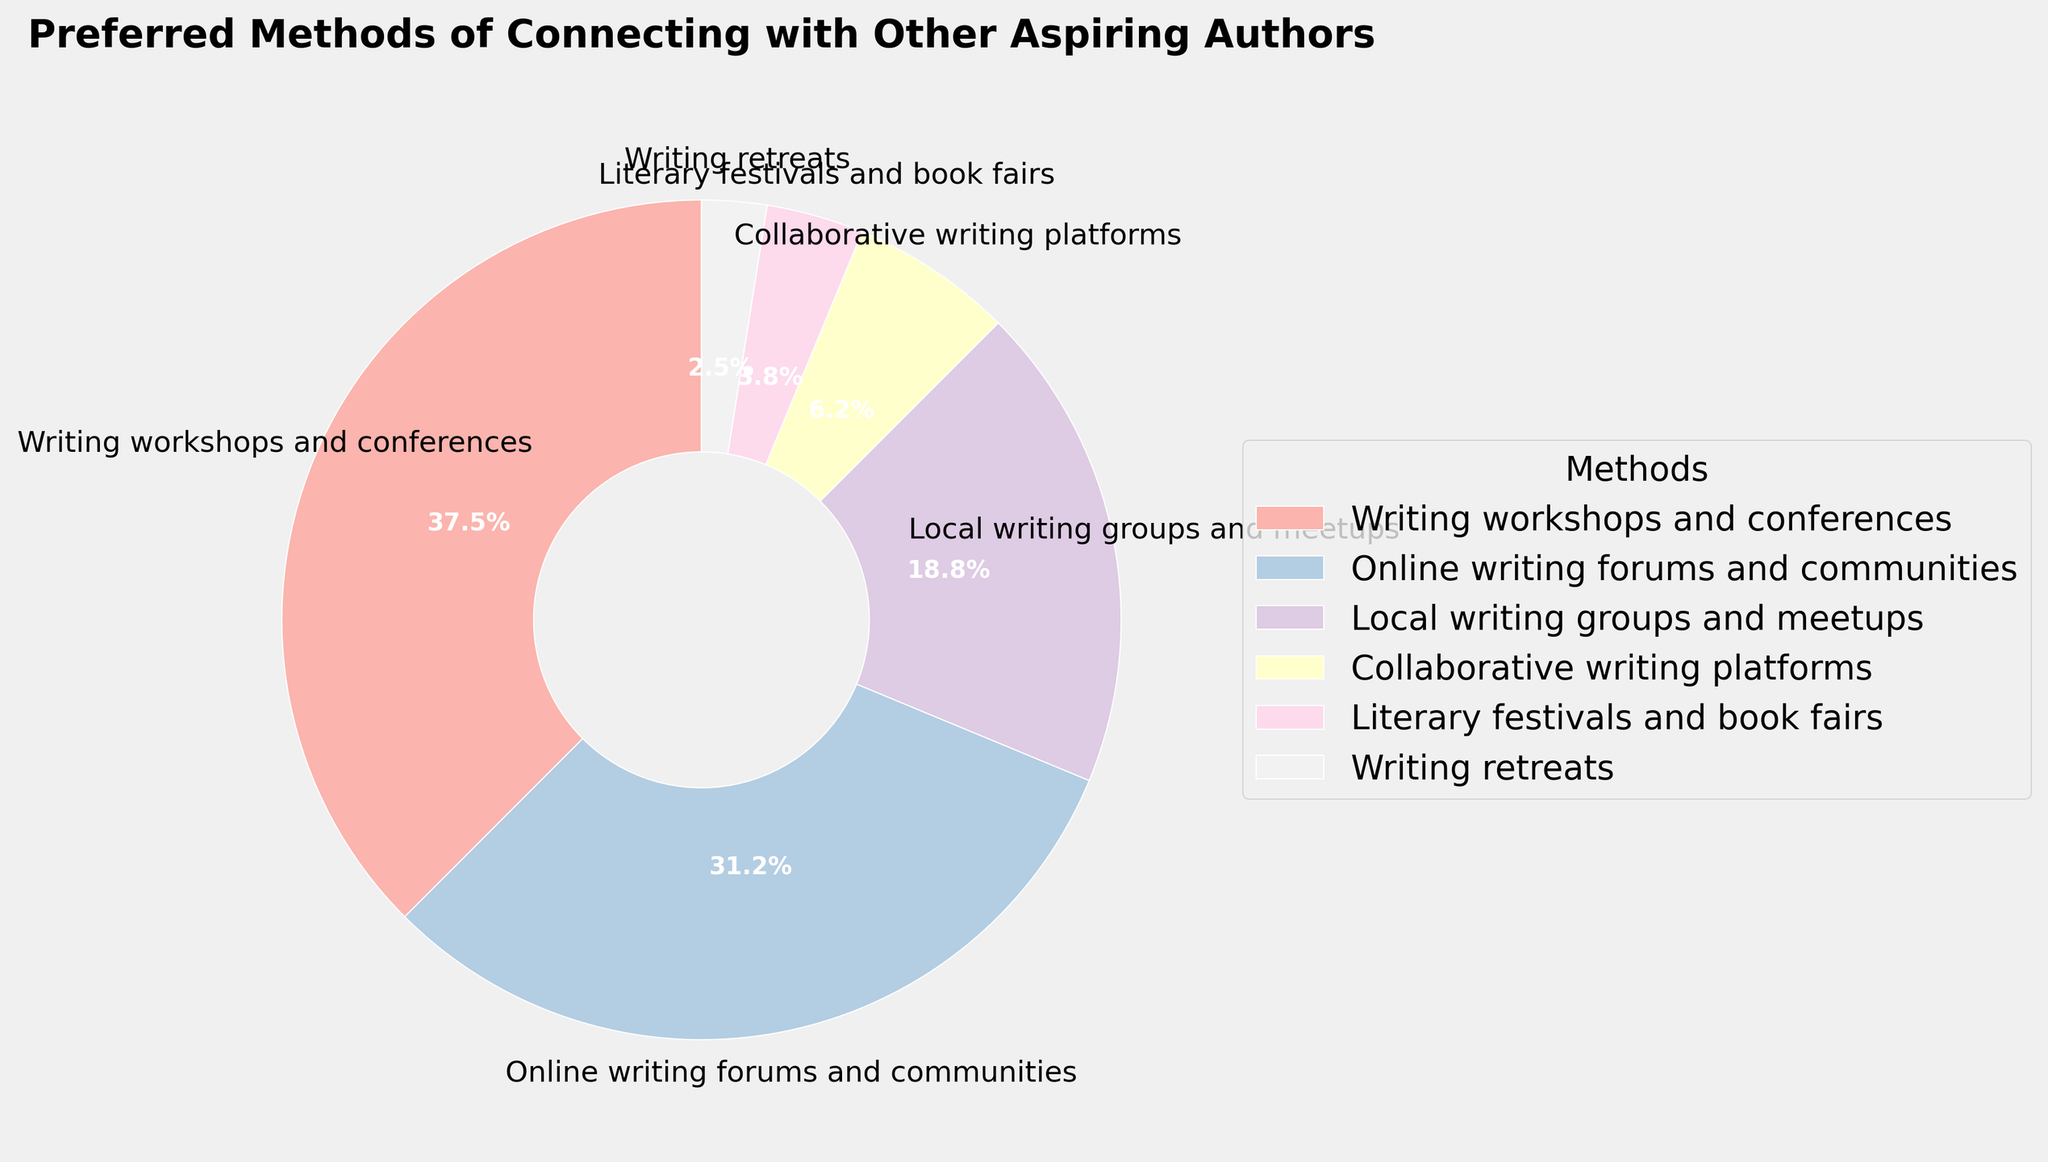What's the most popular method of connecting with other aspiring authors? The segment with the largest percentage (30%) represents the most popular method. In this pie chart, it's "Writing workshops and conferences".
Answer: Writing workshops and conferences Which methods together account for more than half of the preferences? Sum the percentages until the total exceeds 50%. "Writing workshops and conferences" (30%) and "Online writing forums and communities" (25%) together total 55%.
Answer: Writing workshops and conferences, Online writing forums and communities Which two methods are the least preferred? The segments with the smallest percentages represent the least preferred methods. These are "Writing retreats" (2%) and "Literary festivals and book fairs" (3%).
Answer: Writing retreats, Literary festivals and book fairs Which method has a segment with a slice color closest to the top center of the pie? In this pie chart, the slice closest to the 12 o’clock position is the start point and represents "Writing workshops and conferences".
Answer: Writing workshops and conferences What is the combined percentage of all methods except the top two preferred ones? Subtract the sum of the top two methods (30% + 25% = 55%) from 100%. This gives 100% - 55% = 45%.
Answer: 45% Which method's segment is between the colors representing "Local writing groups and meetups" and "Literary festivals and book fairs"? Visually inspect the chart and identify the segment between these two. "Collaborative writing platforms" is located between "Local writing groups and meetups" and "Literary festivals and book fairs".
Answer: Collaborative writing platforms How does the percentage of "Online writing forums and communities" compare to "Local writing groups and meetups"? "Online writing forums and communities" has a percentage of 25%, which is higher than "Local writing groups and meetups" at 15%.
Answer: Higher If the preferences for "Online writing forums and communities" and "Collaborative writing platforms" were combined, what would their total percentage be? Sum the two percentages: 25% (Online writing forums and communities) + 5% (Collaborative writing platforms) equals 30%.
Answer: 30% What is the average percentage of all the methods displayed in the chart? Sum all percentages (30 + 25 + 15 + 5 + 3 + 2 = 80) and divide by the number of methods (6). The average percentage is 80/6 ≈ 13.3%.
Answer: 13.3% 